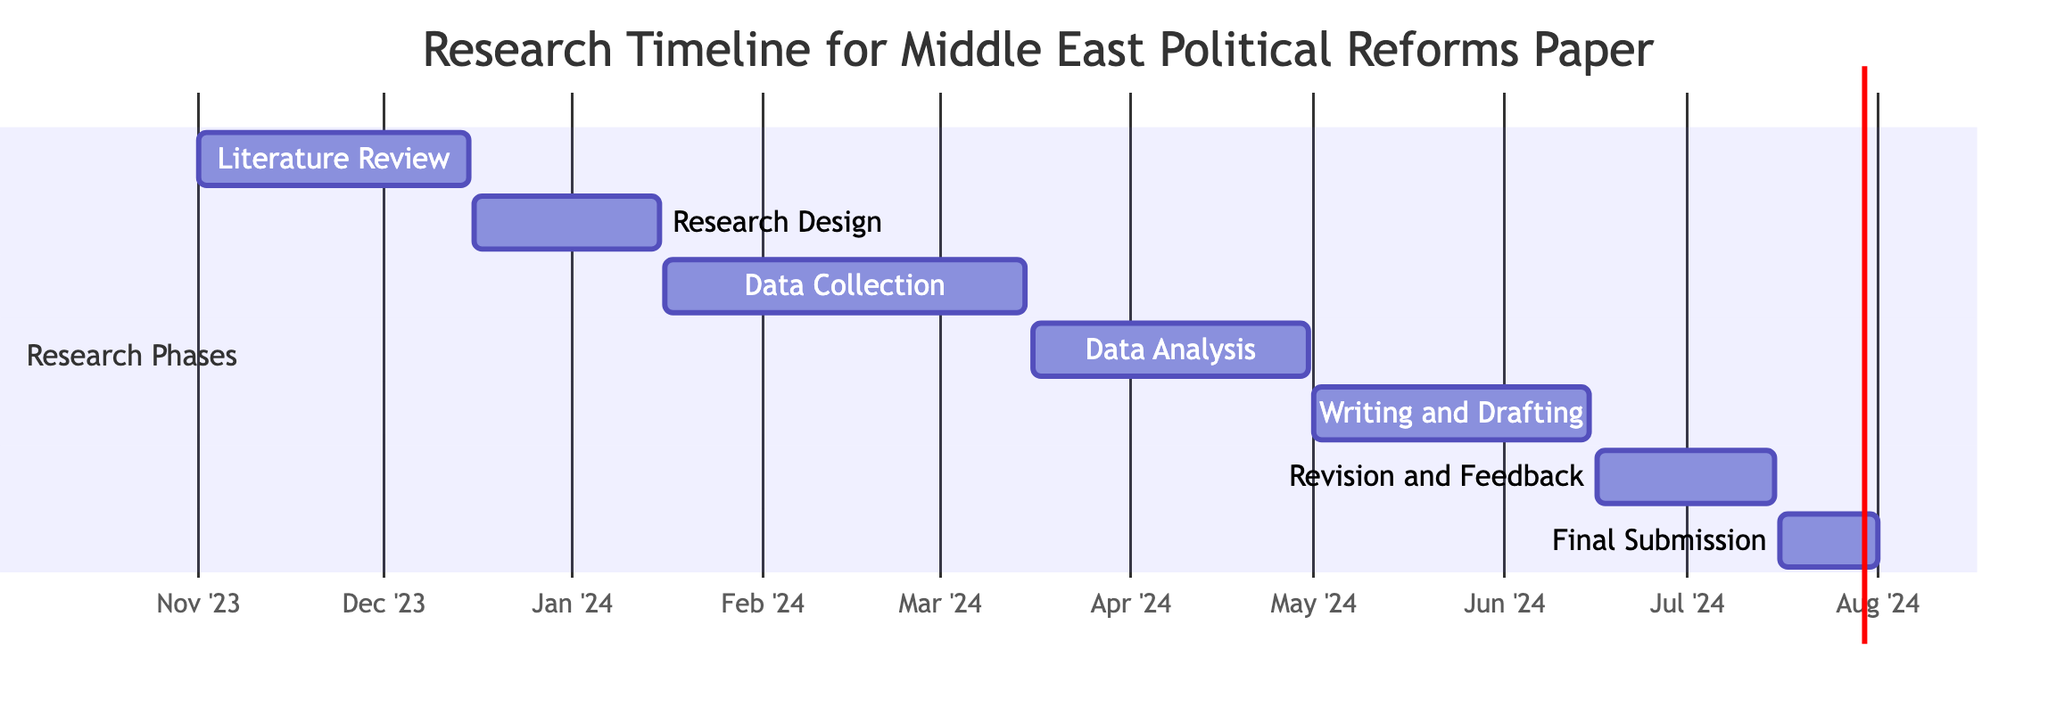What is the duration of the Data Collection phase? The Data Collection phase starts on January 16, 2024, and ends on March 15, 2024. To find the duration, count the number of days between these two dates, which amounts to 59 days.
Answer: 59 days During which months does the Writing and Drafting phase occur? The Writing and Drafting phase starts on May 1, 2024, and ends on June 15, 2024. Therefore, this phase spans two months: May and June.
Answer: May and June What is the overlapping period between Data Analysis and Writing and Drafting? Data Analysis begins on March 16, 2024, and ends on April 30, 2024. Writing and Drafting starts on May 1, 2024, and there is no overlap between these two phases as they are consecutive without any overlapping dates.
Answer: None How many total phases are listed in the timeline? Each phase in the timeline is distinctly listed. By counting them, we find a total of 7 distinct phases: Literature Review, Research Design, Data Collection, Data Analysis, Writing and Drafting, Revision and Feedback, and Final Submission.
Answer: 7 Which phase follows the Revision and Feedback phase? The Revision and Feedback phase ends on July 15, 2024, and the next phase starts on July 16, 2024, which is the Final Submission phase.
Answer: Final Submission What is the earliest start date for any phase? The earliest phase starts on November 1, 2023, corresponding to the Literature Review phase. This is determined by examining the start dates of all the phases listed.
Answer: November 1, 2023 What is the longest phase in terms of duration? To determine the longest phase, we calculate the duration of each phase. Data Collection lasts 59 days, while others last shorter durations. This makes the Data Collection phase the longest in terms of days.
Answer: Data Collection 